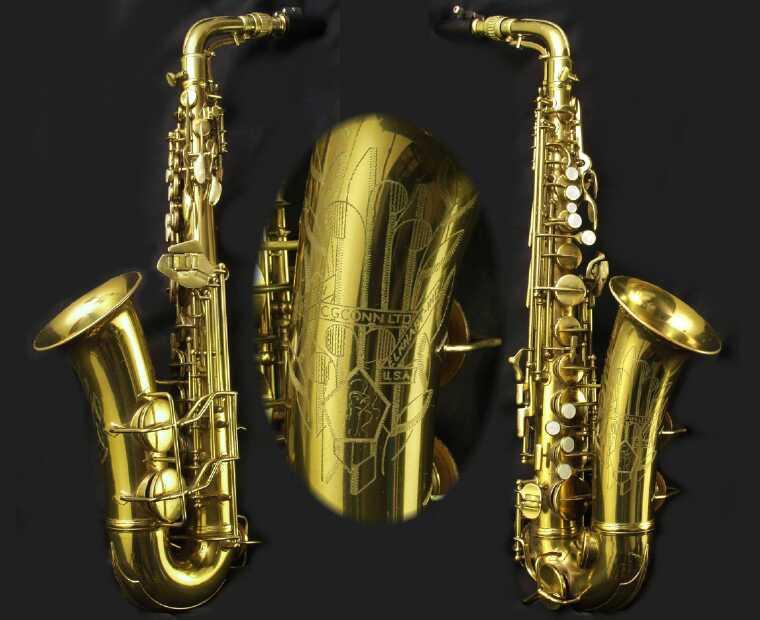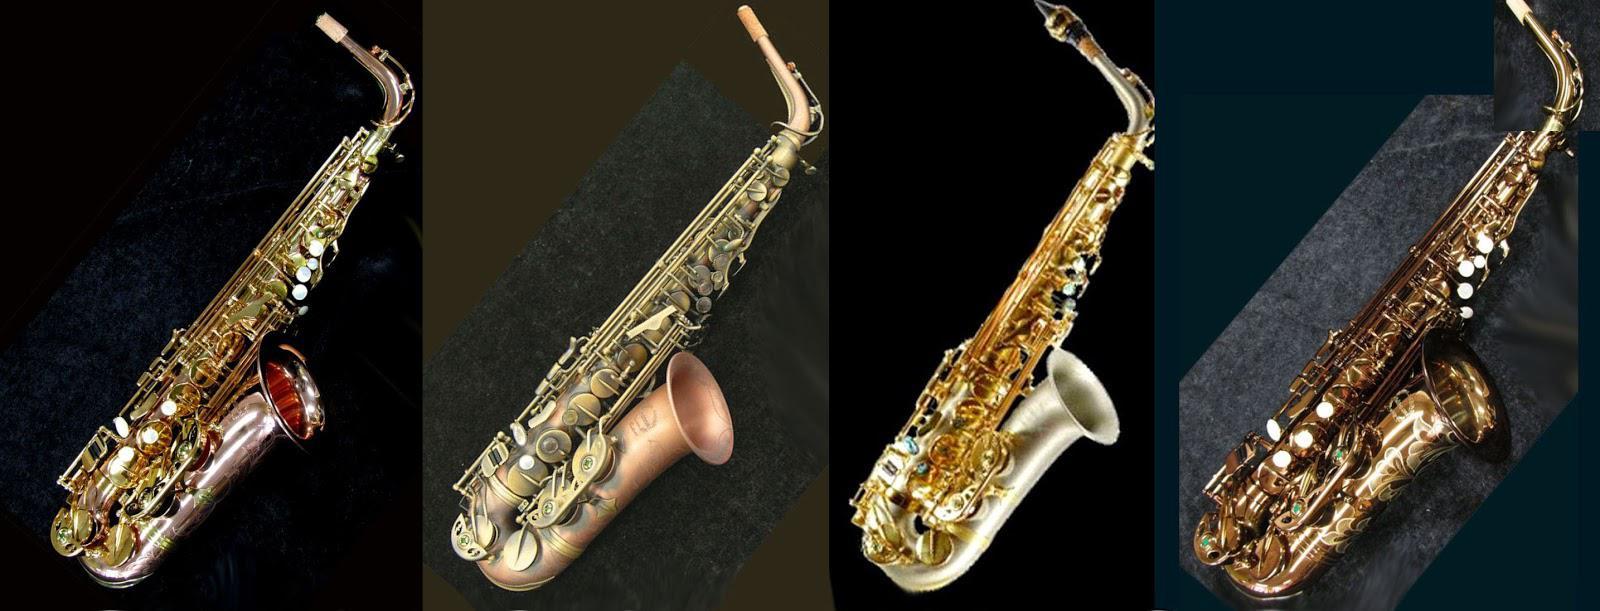The first image is the image on the left, the second image is the image on the right. Considering the images on both sides, is "There are at most four and at least three saxophones in the right image." valid? Answer yes or no. Yes. The first image is the image on the left, the second image is the image on the right. For the images shown, is this caption "In the left image, there is only one saxophone, of which you can see the entire instrument." true? Answer yes or no. No. 